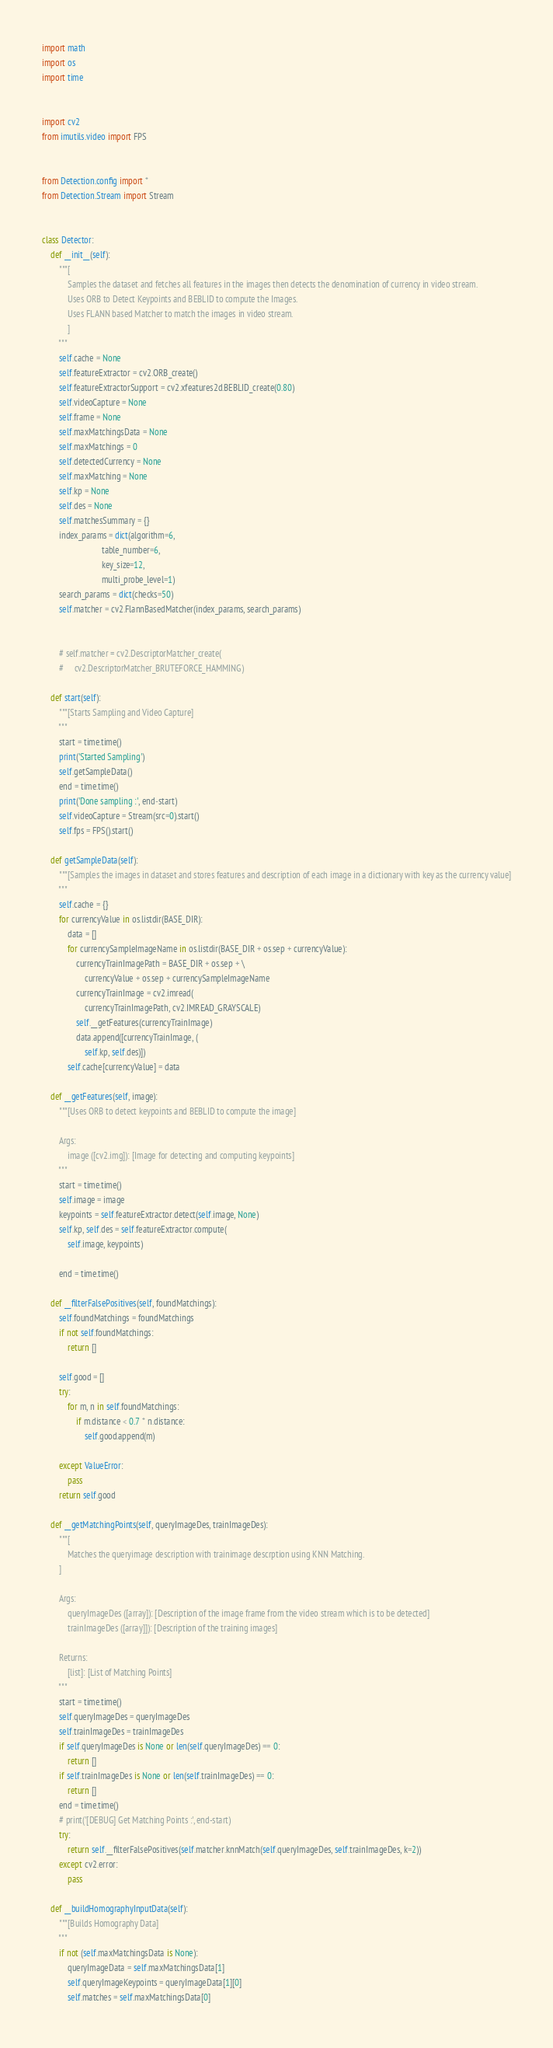<code> <loc_0><loc_0><loc_500><loc_500><_Python_>import math
import os
import time


import cv2
from imutils.video import FPS


from Detection.config import *
from Detection.Stream import Stream


class Detector:
    def __init__(self):
        """[
            Samples the dataset and fetches all features in the images then detects the denomination of currency in video stream.
            Uses ORB to Detect Keypoints and BEBLID to compute the Images.
            Uses FLANN based Matcher to match the images in video stream.
            ]
        """
        self.cache = None
        self.featureExtractor = cv2.ORB_create()
        self.featureExtractorSupport = cv2.xfeatures2d.BEBLID_create(0.80)
        self.videoCapture = None
        self.frame = None
        self.maxMatchingsData = None
        self.maxMatchings = 0
        self.detectedCurrency = None
        self.maxMatching = None
        self.kp = None
        self.des = None
        self.matchesSummary = {}
        index_params = dict(algorithm=6,
                            table_number=6,
                            key_size=12,
                            multi_probe_level=1)
        search_params = dict(checks=50)
        self.matcher = cv2.FlannBasedMatcher(index_params, search_params)
        
        
        # self.matcher = cv2.DescriptorMatcher_create(
        #     cv2.DescriptorMatcher_BRUTEFORCE_HAMMING)

    def start(self):
        """[Starts Sampling and Video Capture]
        """
        start = time.time()
        print('Started Sampling')
        self.getSampleData()
        end = time.time()
        print('Done sampling :', end-start)
        self.videoCapture = Stream(src=0).start()
        self.fps = FPS().start()

    def getSampleData(self):
        """[Samples the images in dataset and stores features and description of each image in a dictionary with key as the currency value]
        """
        self.cache = {}
        for currencyValue in os.listdir(BASE_DIR):
            data = []
            for currencySampleImageName in os.listdir(BASE_DIR + os.sep + currencyValue):
                currencyTrainImagePath = BASE_DIR + os.sep + \
                    currencyValue + os.sep + currencySampleImageName
                currencyTrainImage = cv2.imread(
                    currencyTrainImagePath, cv2.IMREAD_GRAYSCALE)
                self.__getFeatures(currencyTrainImage)
                data.append([currencyTrainImage, (
                    self.kp, self.des)])
            self.cache[currencyValue] = data

    def __getFeatures(self, image):
        """[Uses ORB to detect keypoints and BEBLID to compute the image]

        Args:
            image ([cv2.img]): [Image for detecting and computing keypoints]
        """
        start = time.time()
        self.image = image
        keypoints = self.featureExtractor.detect(self.image, None)
        self.kp, self.des = self.featureExtractor.compute(
            self.image, keypoints)

        end = time.time()

    def __filterFalsePositives(self, foundMatchings):
        self.foundMatchings = foundMatchings
        if not self.foundMatchings:
            return []

        self.good = []
        try:
            for m, n in self.foundMatchings:
                if m.distance < 0.7 * n.distance:
                    self.good.append(m)

        except ValueError:
            pass
        return self.good

    def __getMatchingPoints(self, queryImageDes, trainImageDes):
        """[
            Matches the queryimage description with trainimage descrption using KNN Matching.
        ]

        Args:
            queryImageDes ([array]): [Description of the image frame from the video stream which is to be detected]
            trainImageDes ([array]]): [Description of the training images]

        Returns:
            [list]: [List of Matching Points]
        """
        start = time.time()
        self.queryImageDes = queryImageDes
        self.trainImageDes = trainImageDes
        if self.queryImageDes is None or len(self.queryImageDes) == 0:
            return []
        if self.trainImageDes is None or len(self.trainImageDes) == 0:
            return []
        end = time.time()
        # print('[DEBUG] Get Matching Points :', end-start)
        try:
            return self.__filterFalsePositives(self.matcher.knnMatch(self.queryImageDes, self.trainImageDes, k=2))
        except cv2.error:
            pass

    def __buildHomographyInputData(self):
        """[Builds Homography Data]
        """
        if not (self.maxMatchingsData is None):
            queryImageData = self.maxMatchingsData[1]
            self.queryImageKeypoints = queryImageData[1][0]
            self.matches = self.maxMatchingsData[0]</code> 